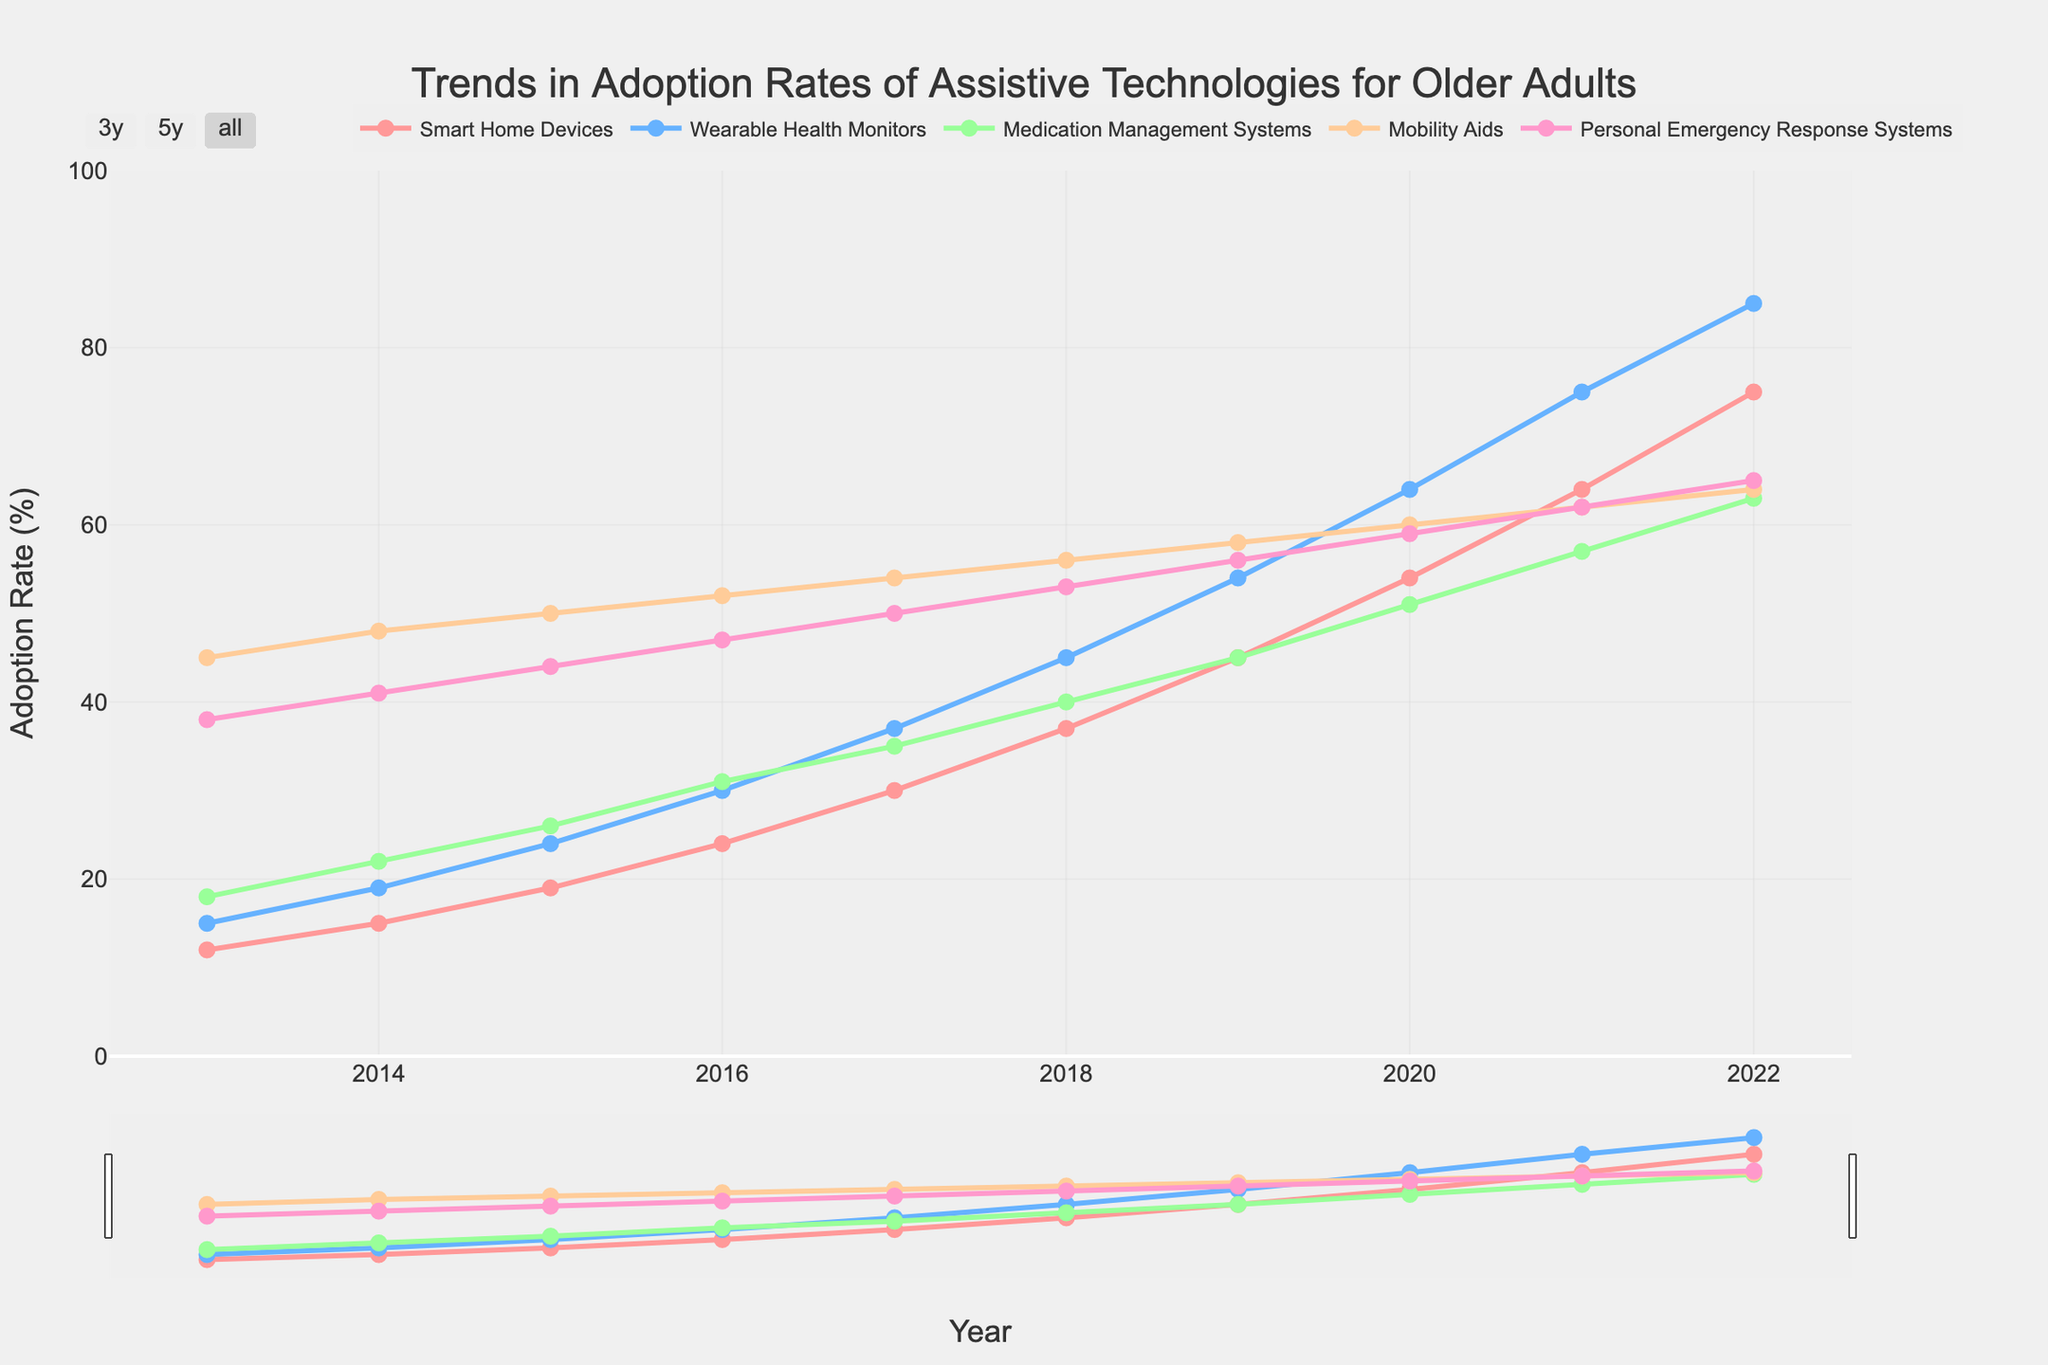What is the overall trend for Smart Home Devices adoption rates over the decade? The adoption rate for Smart Home Devices shows a consistent upward trend from 12% in 2013 to 75% in 2022.
Answer: Consistent upward trend Which assistive technology had the highest adoption rate in 2015? In 2015, Mobility Aids had the highest adoption rate of 50%.
Answer: Mobility Aids What is the difference in adoption rates between Wearable Health Monitors and Medication Management Systems in 2020? In 2020, Wearable Health Monitors had an adoption rate of 64%, and Medication Management Systems had 51%. The difference is 64% - 51% = 13%.
Answer: 13% Compare the adoption rates of Smart Home Devices and Personal Emergency Response Systems in 2017. Which one is higher? In 2017, Smart Home Devices had an adoption rate of 30%, while Personal Emergency Response Systems had 50%. Personal Emergency Response Systems is higher.
Answer: Personal Emergency Response Systems How does the adoption rate of Medication Management Systems change from 2018 to 2021? The adoption rate of Medication Management Systems increased from 40% in 2018 to 57% in 2021. The change is 57% - 40% = 17%.
Answer: Increased by 17% Calculate the average adoption rate of Mobility Aids over the three years from 2019 to 2021. The adoption rates for Mobility Aids from 2019 to 2021 are 58%, 60%, and 62%. The average is (58 + 60 + 62) / 3 = 60%.
Answer: 60% Which category shows the fastest growth in adoption rates over the decade? From 2013 to 2022, Smart Home Devices grew from 12% to 75%, an increase of 63%. This is the fastest growth among all categories.
Answer: Smart Home Devices What visual attribute distinguishes Wearable Health Monitors in the figure? Wearable Health Monitors are represented by a blue line with markers.
Answer: Blue line What is the adoption rate of Personal Emergency Response Systems in 2022? In 2022, the adoption rate of Personal Emergency Response Systems is 65%.
Answer: 65% 